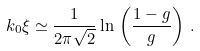<formula> <loc_0><loc_0><loc_500><loc_500>k _ { 0 } \xi \simeq \frac { 1 } { 2 \pi \sqrt { 2 } } \ln \, \left ( \frac { 1 - g } { g } \right ) \, .</formula> 